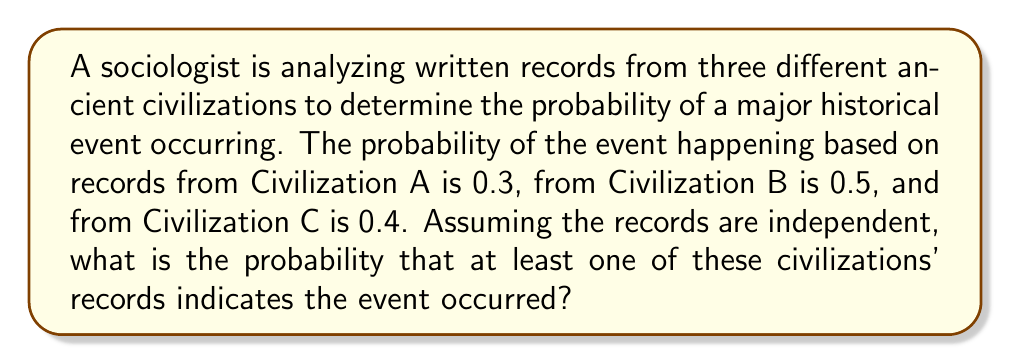Can you answer this question? Let's approach this step-by-step:

1) First, we need to understand that we're looking for the probability of at least one civilization's records indicating the event occurred. This is equivalent to 1 minus the probability that none of the civilizations' records indicate the event occurred.

2) Let's define our events:
   A: Civilization A's records indicate the event occurred
   B: Civilization B's records indicate the event occurred
   C: Civilization C's records indicate the event occurred

3) We're given:
   P(A) = 0.3
   P(B) = 0.5
   P(C) = 0.4

4) The probability that A does not occur is 1 - P(A) = 1 - 0.3 = 0.7
   Similarly, P(not B) = 1 - 0.5 = 0.5 and P(not C) = 1 - 0.4 = 0.6

5) Since the records are independent, the probability that none of the events occur is:
   P(not A and not B and not C) = P(not A) × P(not B) × P(not C)

6) Let's calculate this:
   P(none occur) = 0.7 × 0.5 × 0.6 = 0.21

7) Therefore, the probability that at least one occurs is:
   P(at least one occurs) = 1 - P(none occur) = 1 - 0.21 = 0.79

8) We can also express this as a percentage: 0.79 × 100% = 79%
Answer: 0.79 or 79% 